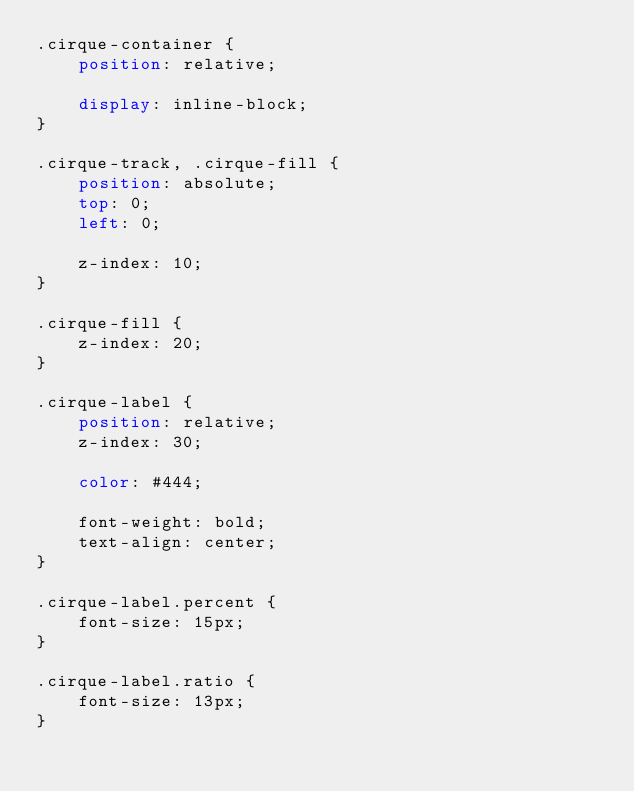<code> <loc_0><loc_0><loc_500><loc_500><_CSS_>.cirque-container {
	position: relative;
	
	display: inline-block;
}

.cirque-track, .cirque-fill {
	position: absolute;
	top: 0;
	left: 0;
	
	z-index: 10;
}

.cirque-fill {
	z-index: 20;
}

.cirque-label {
	position: relative;
	z-index: 30;
	
	color: #444;
	
	font-weight: bold;
	text-align: center;	
}

.cirque-label.percent {	
	font-size: 15px;
}

.cirque-label.ratio {
	font-size: 13px;
}</code> 